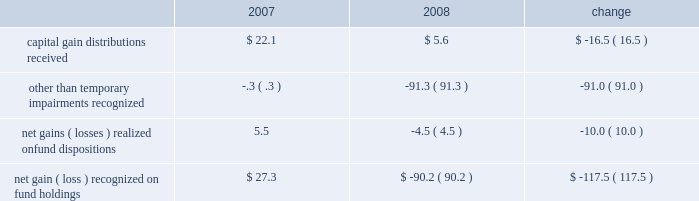Administrative fees , which increased $ 5.8 million to $ 353.9 million , are generally offset by related operating expenses that are incurred to provide services to the funds and their investors .
Our largest expense , compensation and related costs , increased $ 18.4 million or 2.3% ( 2.3 % ) from 2007 .
This increase includes $ 37.2 million in salaries resulting from an 8.4% ( 8.4 % ) increase in our average staff count and an increase of our associates 2019 base salaries at the beginning of the year .
At december 31 , 2008 , we employed 5385 associates , up 6.0% ( 6.0 % ) from the end of 2007 , primarily to add capabilities and support increased volume-related activities and other growth over the past few years .
Over the course of 2008 , we slowed the growth of our associate base from earlier plans and the prior year .
We also reduced our annual bonuses $ 27.6 million versus the 2007 year in response to unfavorable financial market conditions that negatively impacted our operating results .
The balance of the increase is attributable to higher employee benefits and employment-related expenses , including an increase of $ 5.7 million in stock-based compensation .
After higher spending during the first quarter of 2008 versus 2007 , investor sentiment in the uncertain and volatile market environment caused us to reduce advertising and promotion spending , which for the year was down $ 3.8 million from 2007 .
Occupancy and facility costs together with depreciation expense increased $ 18 million , or 12% ( 12 % ) compared to 2007 .
We expanded and renovated our facilities in 2008 to accommodate the growth in our associates to meet business demands .
Other operating expenses were up $ 3.3 million from 2007 .
We increased our spending $ 9.8 million , primarily for professional fees and information and other third-party services .
Reductions in travel and charitable contributions partially offset these increases .
Our non-operating investment activity resulted in a net loss of $ 52.3 million in 2008 as compared to a net gain of $ 80.4 million in 2007 .
This change of $ 132.7 million is primarily attributable to losses recognized in 2008 on our investments in sponsored mutual funds , which resulted from declines in financial market values during the year. .
We recognized other than temporary impairments of our investments in sponsored mutual funds because of declines in fair value below cost for an extended period .
The significant declines in fair value below cost that occurred in 2008 were generally attributable to adverse market conditions .
In addition , income from money market and bond fund holdings was $ 19.3 million lower than in 2007 due to the significantly lower interest rate environment of 2008 .
Lower interest rates also led to substantial capital appreciation on our $ 40 million holding of u.s .
Treasury notes that we sold in december 2008 at a $ 2.6 million gain .
The 2008 provision for income taxes as a percentage of pretax income is 38.4% ( 38.4 % ) , up from 37.7% ( 37.7 % ) in 2007 , primarily to reflect changes in state income tax rates and regulations and certain adjustments made prospectively based on our annual income tax return filings for 2007 .
C a p i t a l r e s o u r c e s a n d l i q u i d i t y .
During 2009 , stockholders 2019 equity increased from $ 2.5 billion to $ 2.9 billion .
We repurchased nearly 2.3 million common shares for $ 67 million in 2009 .
Tangible book value is $ 2.2 billion at december 31 , 2009 , and our cash and cash equivalents and our mutual fund investment holdings total $ 1.4 billion .
Given the availability of these financial resources , we do not maintain an available external source of liquidity .
On january 20 , 2010 , we purchased a 26% ( 26 % ) equity interest in uti asset management company and an affiliate for $ 142.4 million .
We funded the acquisition from our cash holdings .
In addition to the pending uti acquisition , we had outstanding commitments to fund other investments totaling $ 35.4 million at december 31 , 2009 .
We presently anticipate funding 2010 property and equipment expenditures of about $ 150 million from our cash balances and operating cash inflows .
22 t .
Rowe price group annual report 2009 .
What were the total occupancy and facility costs in 2007 , in millions of dollars? 
Computations: (18 / 12%)
Answer: 150.0. 